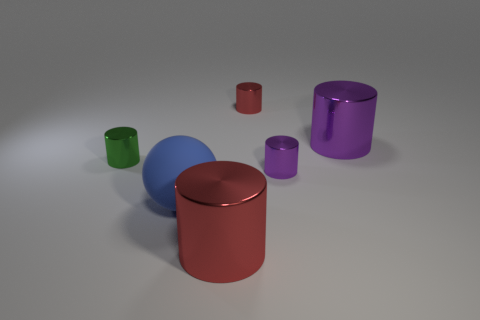Add 3 small cylinders. How many objects exist? 9 Subtract all cylinders. How many objects are left? 1 Add 1 large metallic things. How many large metallic things are left? 3 Add 2 purple metallic cylinders. How many purple metallic cylinders exist? 4 Subtract 0 yellow cubes. How many objects are left? 6 Subtract all tiny green shiny things. Subtract all tiny cylinders. How many objects are left? 2 